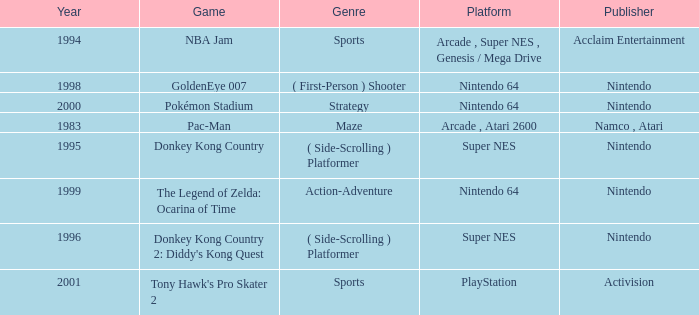Which Genre has a Game of tony hawk's pro skater 2? Sports. 